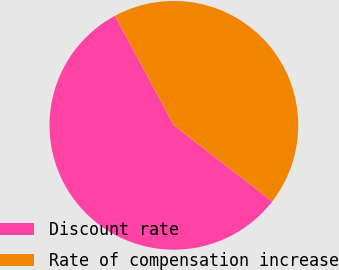Convert chart to OTSL. <chart><loc_0><loc_0><loc_500><loc_500><pie_chart><fcel>Discount rate<fcel>Rate of compensation increase<nl><fcel>56.65%<fcel>43.35%<nl></chart> 